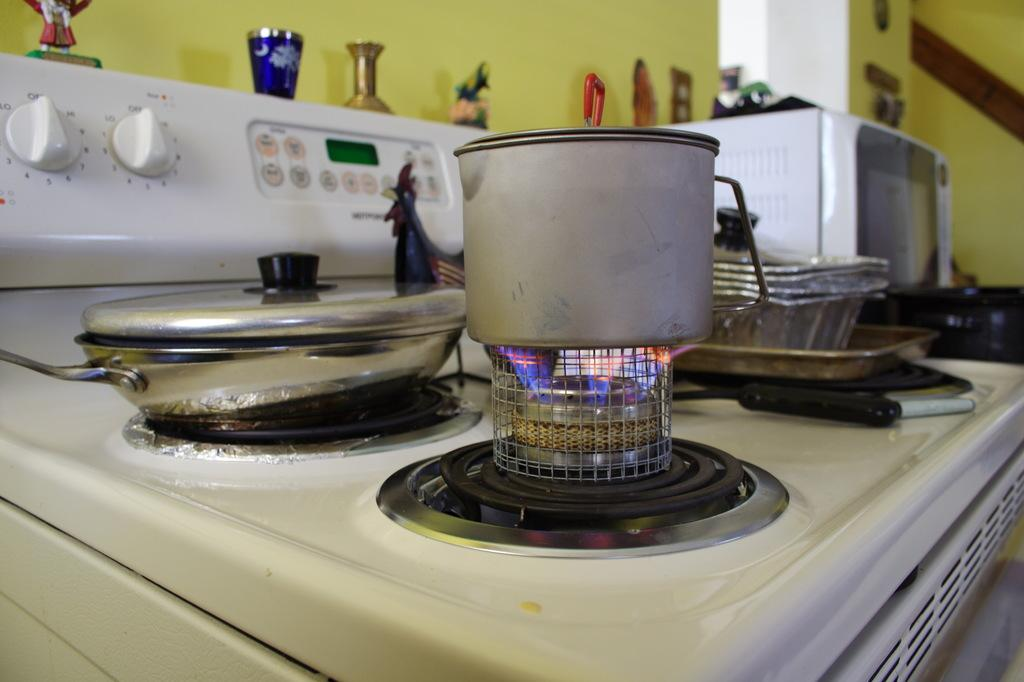What is the main object in the middle of the image? There is a stove in the middle of the image. What can be seen in the background of the image? There is a wall in the background of the image. What is located on the left side of the image? There are objects on the left side of the image. What type of whip is being used to stir the pot on the stove in the image? There is no whip present in the image, and the stove does not have a pot on it. How many rods can be seen supporting the wall in the image? There are no rods supporting the wall in the image; it is a solid structure. 